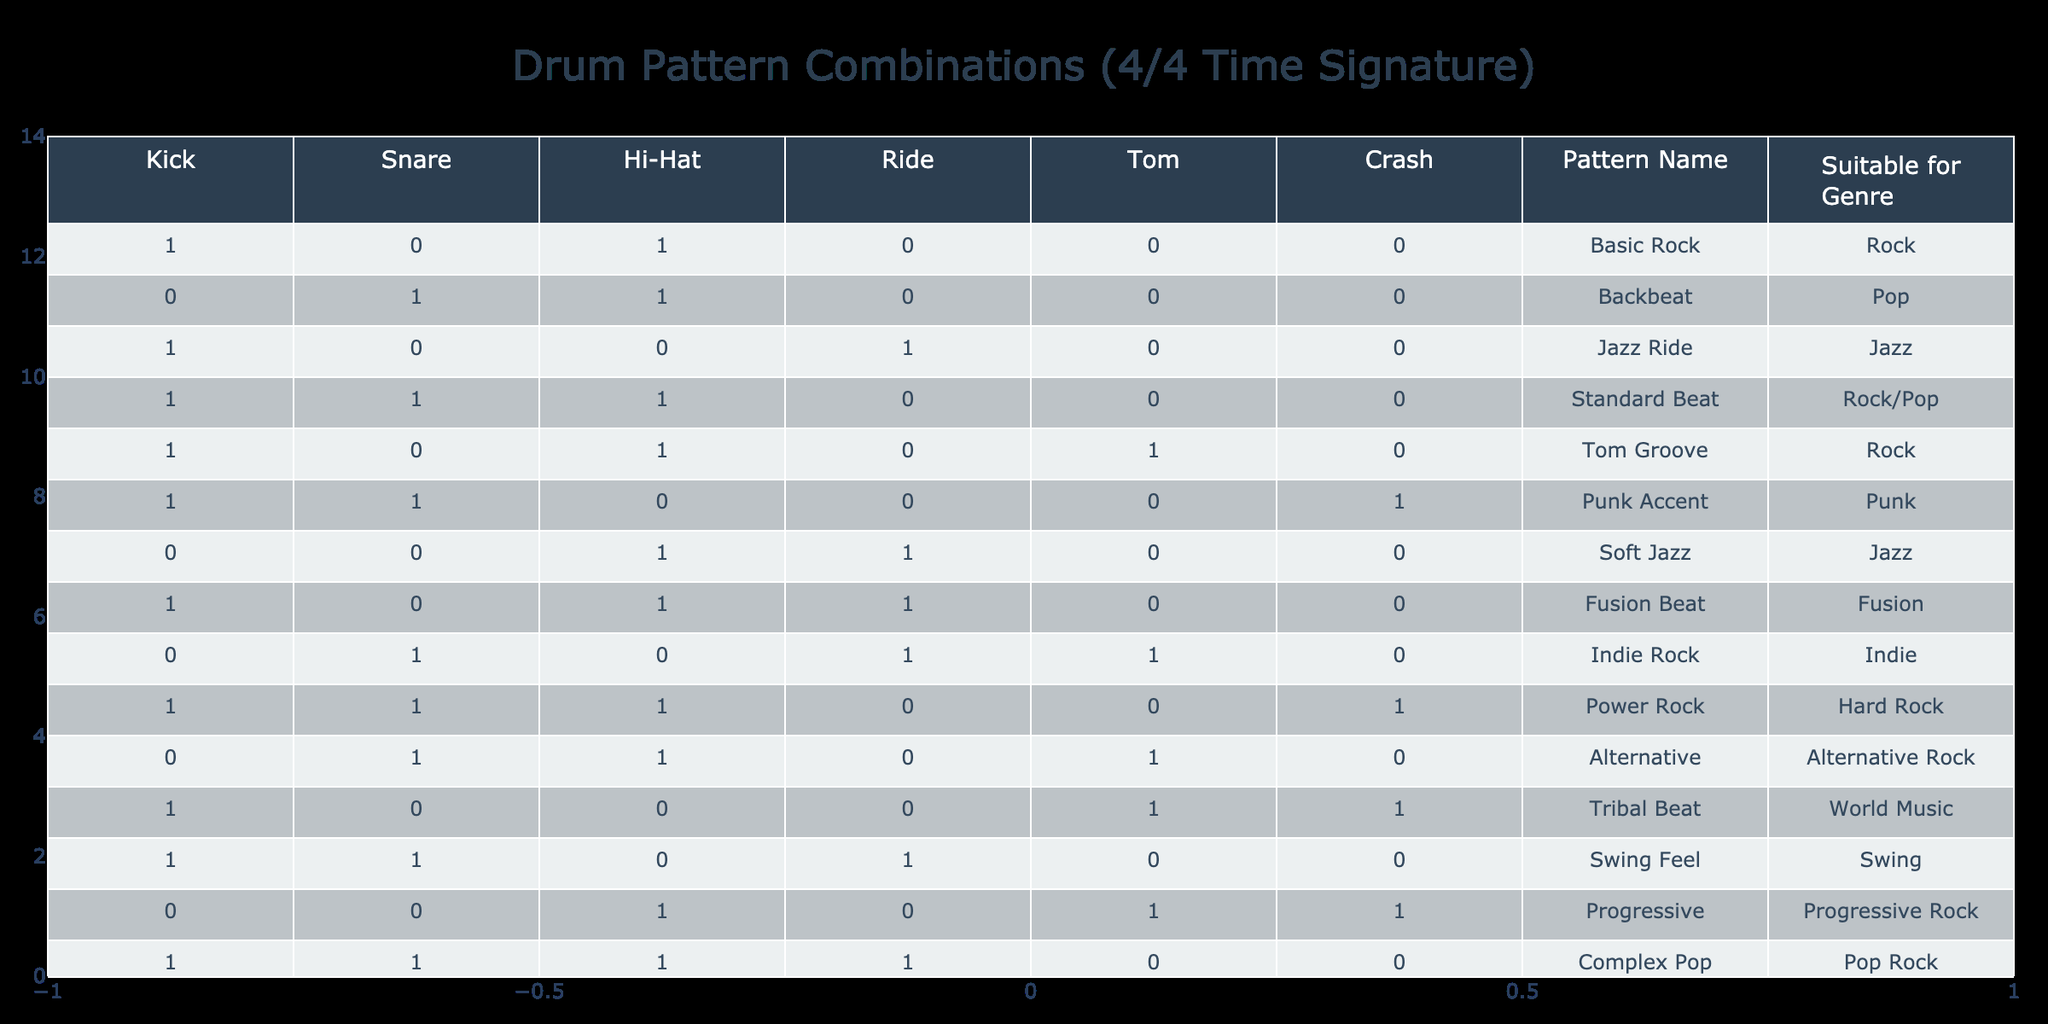What is the pattern name suitable for the Punk genre? In the table, I look for the row where the genre is Punk. I find the row with the pattern name "Punk Accent" in the column.
Answer: Punk Accent How many patterns include the Snare drum? I scan the Snare column to count how many times it has a value of 1. The patterns "Backbeat," "Standard Beat," "Punk Accent," "Alternative," and "Complex Pop" all have a Snare value of 1. That adds up to five patterns.
Answer: 5 Which pattern has both Hi-Hat and Tom drums present? I check the combinations for Hi-Hat and Tom in each pattern. The only pattern that shows 1 in both the Hi-Hat and Tom columns is "Tom Groove."
Answer: Tom Groove Is the "Fusion Beat" pattern suitable for the genre Jazz? I check the row for the "Fusion Beat" and see that it is categorized under the Fusion genre, not Jazz. Therefore, it is not suitable for Jazz.
Answer: No What is the total number of patterns that feature the Crash cymbal? I look at the Crash column to see how many patterns have a value of 1. The patterns "Punk Accent," "Tribal Beat," and "Complex Pop" have a 1 in the Crash column. That's three patterns in total.
Answer: 3 Which pattern is applicable for both Rock and Pop genres? I locate the rows that indicate compatibility with both Rock and Pop in the "Suitable for Genre" column. "Standard Beat" qualifies since it is marked for both genres.
Answer: Standard Beat How many patterns contain the Kick drum but not the Crash cymbal? I first find all patterns that have a Kick value of 1: "Basic Rock," "Jazz Ride," "Standard Beat," "Tom Groove," "Power Rock," "Tribal Beat," and "Swing Feel." Next, I filter out those that also have a Crash value of 1, which leaves me with "Basic Rock," "Jazz Ride," "Standard Beat," "Tom Groove," and "Swing Feel." That’s a total of five patterns.
Answer: 5 Is "Soft Jazz" a suitable pattern for the genre Rock? In the row for "Soft Jazz," it indicates that it is suitable only for the Jazz genre. Since Rock is not listed, the answer is no.
Answer: No What percentage of patterns feature the Hi-Hat? I analyze the Hi-Hat column and see that 8 out of 12 patterns include Hi-Hat with a value of 1. To find the percentage, I calculate (8 / 12) * 100, which results in approximately 66.67%.
Answer: 66.67% 